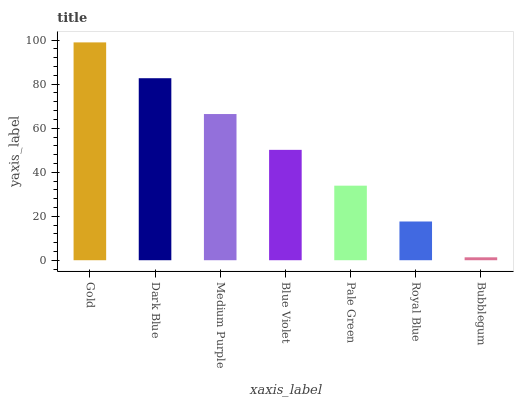Is Bubblegum the minimum?
Answer yes or no. Yes. Is Gold the maximum?
Answer yes or no. Yes. Is Dark Blue the minimum?
Answer yes or no. No. Is Dark Blue the maximum?
Answer yes or no. No. Is Gold greater than Dark Blue?
Answer yes or no. Yes. Is Dark Blue less than Gold?
Answer yes or no. Yes. Is Dark Blue greater than Gold?
Answer yes or no. No. Is Gold less than Dark Blue?
Answer yes or no. No. Is Blue Violet the high median?
Answer yes or no. Yes. Is Blue Violet the low median?
Answer yes or no. Yes. Is Dark Blue the high median?
Answer yes or no. No. Is Royal Blue the low median?
Answer yes or no. No. 